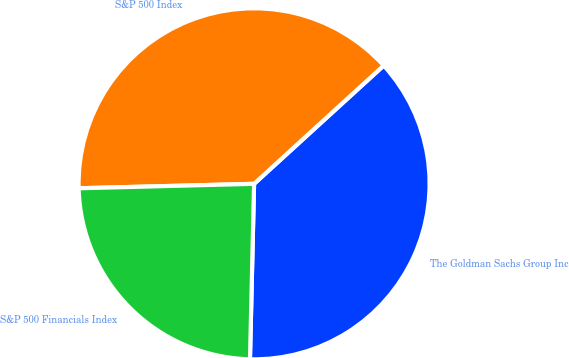Convert chart to OTSL. <chart><loc_0><loc_0><loc_500><loc_500><pie_chart><fcel>The Goldman Sachs Group Inc<fcel>S&P 500 Index<fcel>S&P 500 Financials Index<nl><fcel>37.14%<fcel>38.63%<fcel>24.22%<nl></chart> 